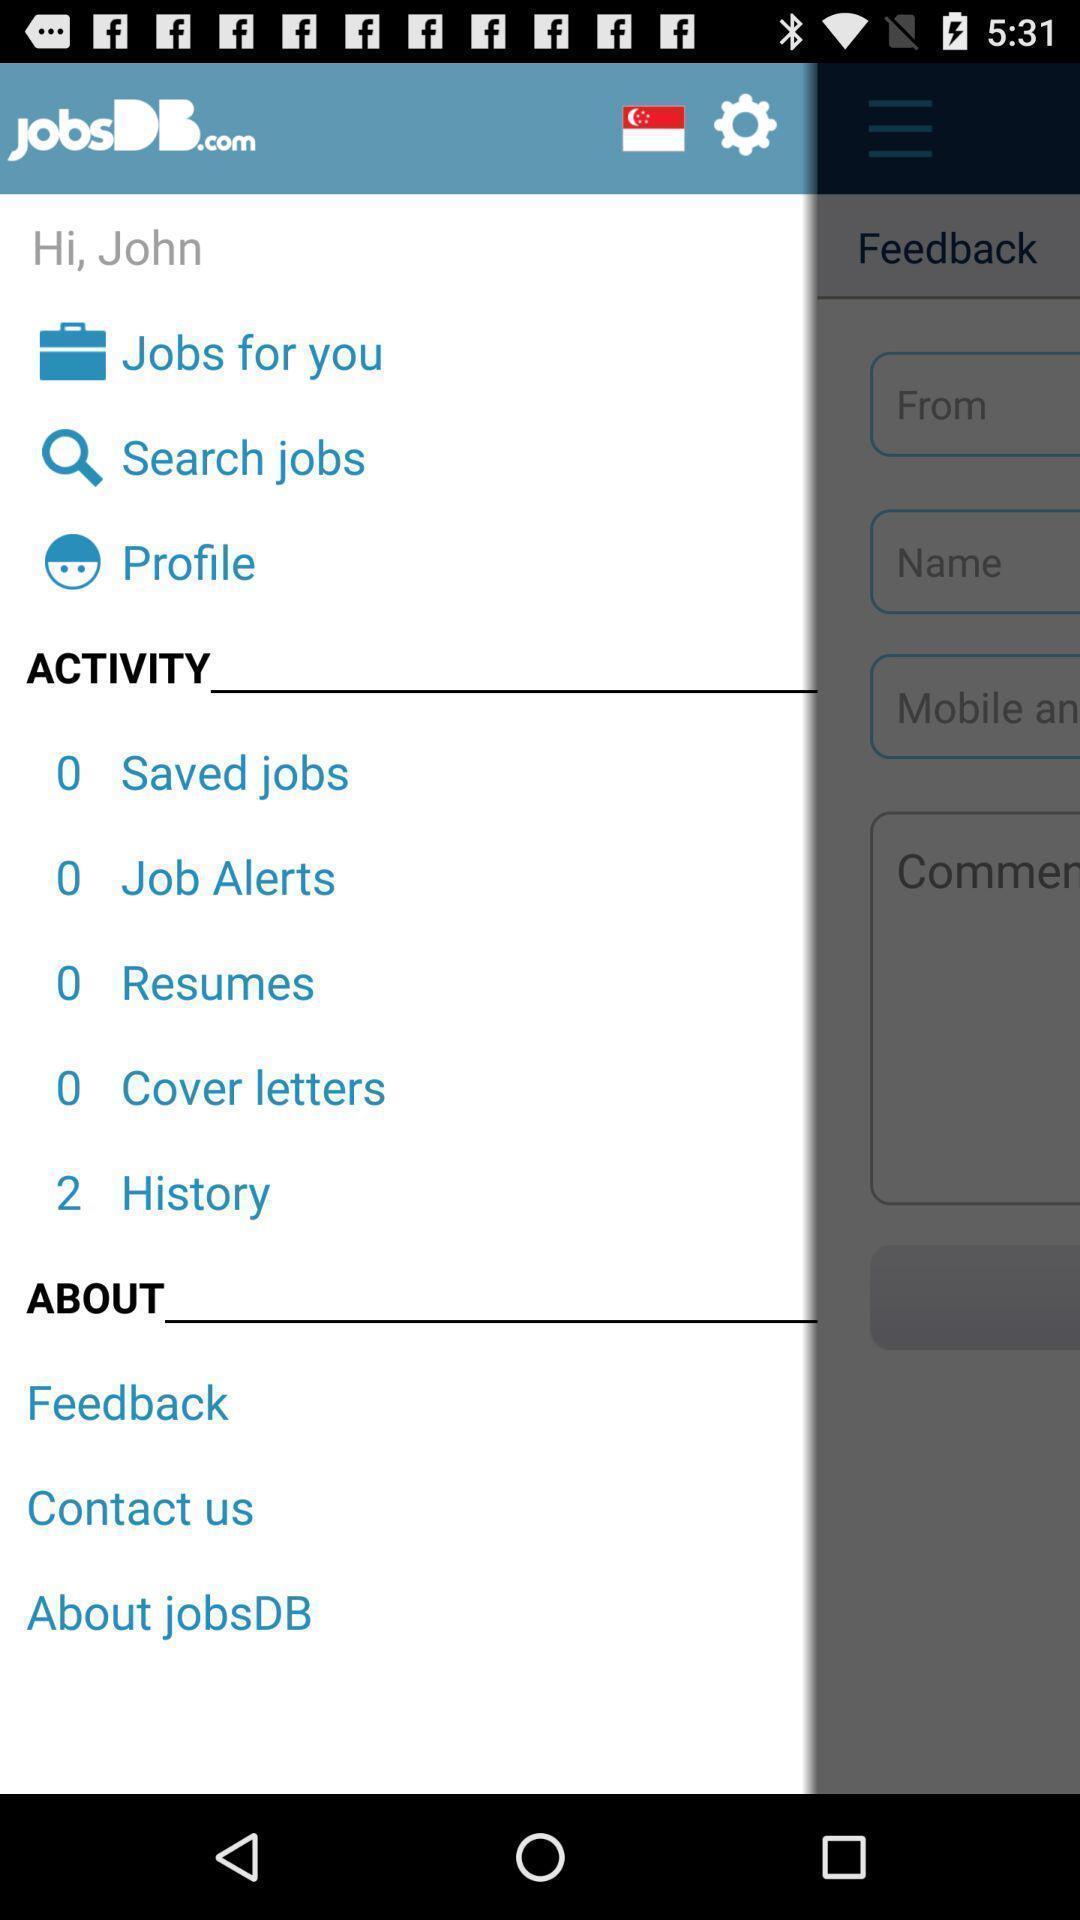What details can you identify in this image? Screen shows about searching of jobs. 